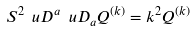<formula> <loc_0><loc_0><loc_500><loc_500>S ^ { 2 } \ u D ^ { a } \ u D _ { a } Q ^ { ( k ) } = k ^ { 2 } Q ^ { ( k ) }</formula> 